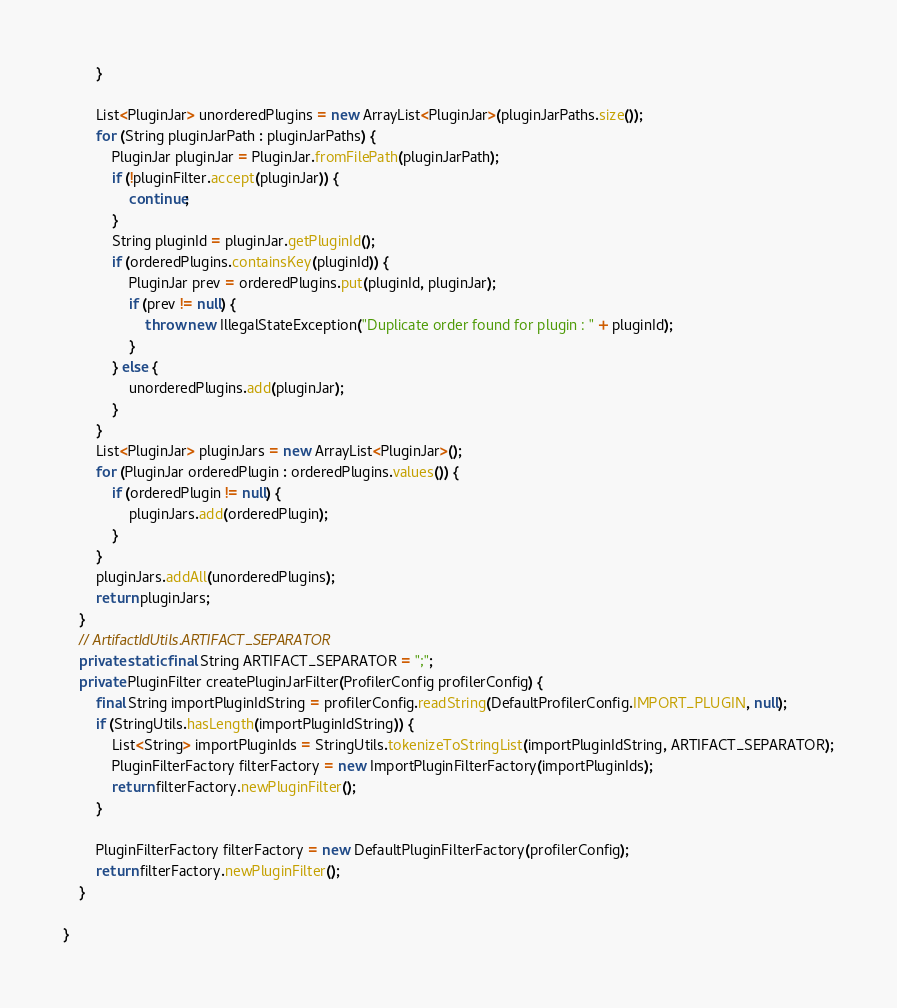<code> <loc_0><loc_0><loc_500><loc_500><_Java_>        }

        List<PluginJar> unorderedPlugins = new ArrayList<PluginJar>(pluginJarPaths.size());
        for (String pluginJarPath : pluginJarPaths) {
            PluginJar pluginJar = PluginJar.fromFilePath(pluginJarPath);
            if (!pluginFilter.accept(pluginJar)) {
                continue;
            }
            String pluginId = pluginJar.getPluginId();
            if (orderedPlugins.containsKey(pluginId)) {
                PluginJar prev = orderedPlugins.put(pluginId, pluginJar);
                if (prev != null) {
                    throw new IllegalStateException("Duplicate order found for plugin : " + pluginId);
                }
            } else {
                unorderedPlugins.add(pluginJar);
            }
        }
        List<PluginJar> pluginJars = new ArrayList<PluginJar>();
        for (PluginJar orderedPlugin : orderedPlugins.values()) {
            if (orderedPlugin != null) {
                pluginJars.add(orderedPlugin);
            }
        }
        pluginJars.addAll(unorderedPlugins);
        return pluginJars;
    }
    // ArtifactIdUtils.ARTIFACT_SEPARATOR
    private static final String ARTIFACT_SEPARATOR = ";";
    private PluginFilter createPluginJarFilter(ProfilerConfig profilerConfig) {
        final String importPluginIdString = profilerConfig.readString(DefaultProfilerConfig.IMPORT_PLUGIN, null);
        if (StringUtils.hasLength(importPluginIdString)) {
            List<String> importPluginIds = StringUtils.tokenizeToStringList(importPluginIdString, ARTIFACT_SEPARATOR);
            PluginFilterFactory filterFactory = new ImportPluginFilterFactory(importPluginIds);
            return filterFactory.newPluginFilter();
        }

        PluginFilterFactory filterFactory = new DefaultPluginFilterFactory(profilerConfig);
        return filterFactory.newPluginFilter();
    }

}
</code> 